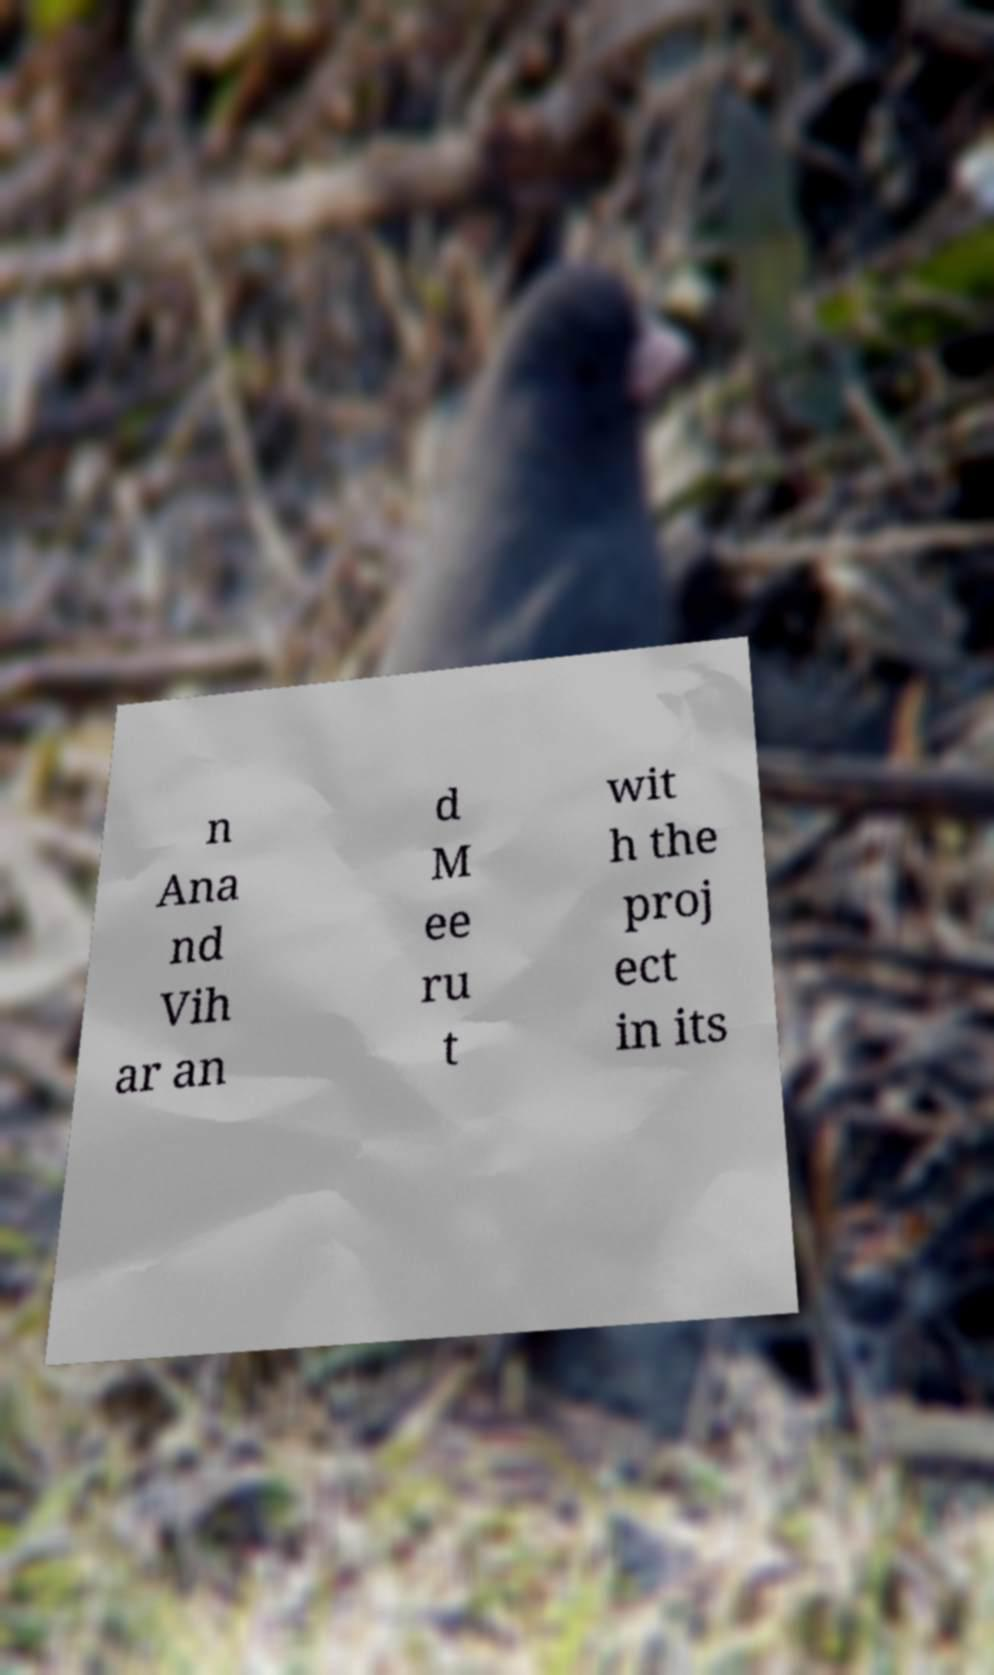Could you assist in decoding the text presented in this image and type it out clearly? n Ana nd Vih ar an d M ee ru t wit h the proj ect in its 